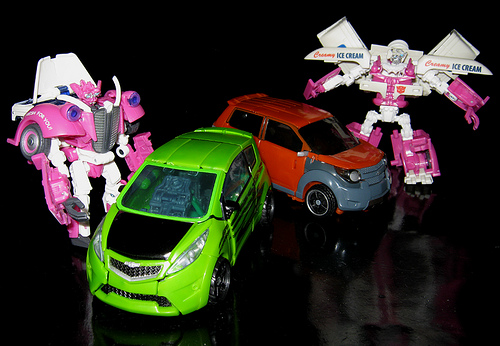<image>
Is there a toy next to the toy? Yes. The toy is positioned adjacent to the toy, located nearby in the same general area. 